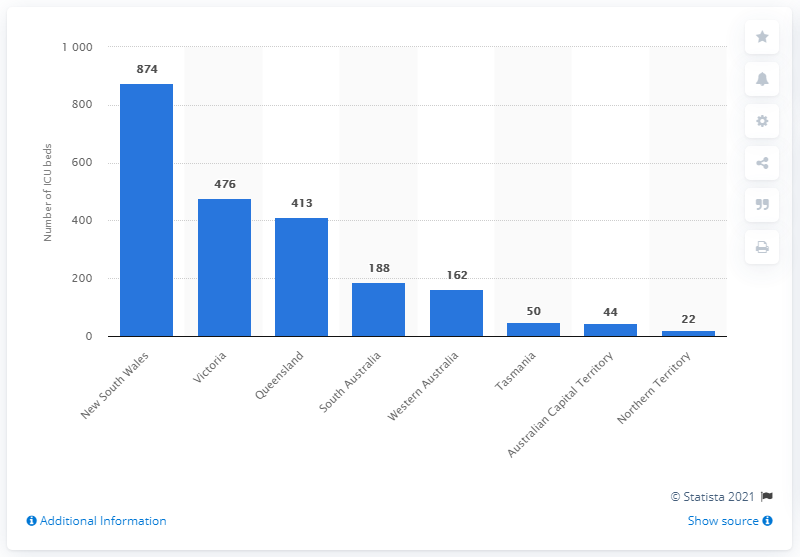Point out several critical features in this image. In the year 2018, New South Wales had a total of 874 ICU beds available for use. 